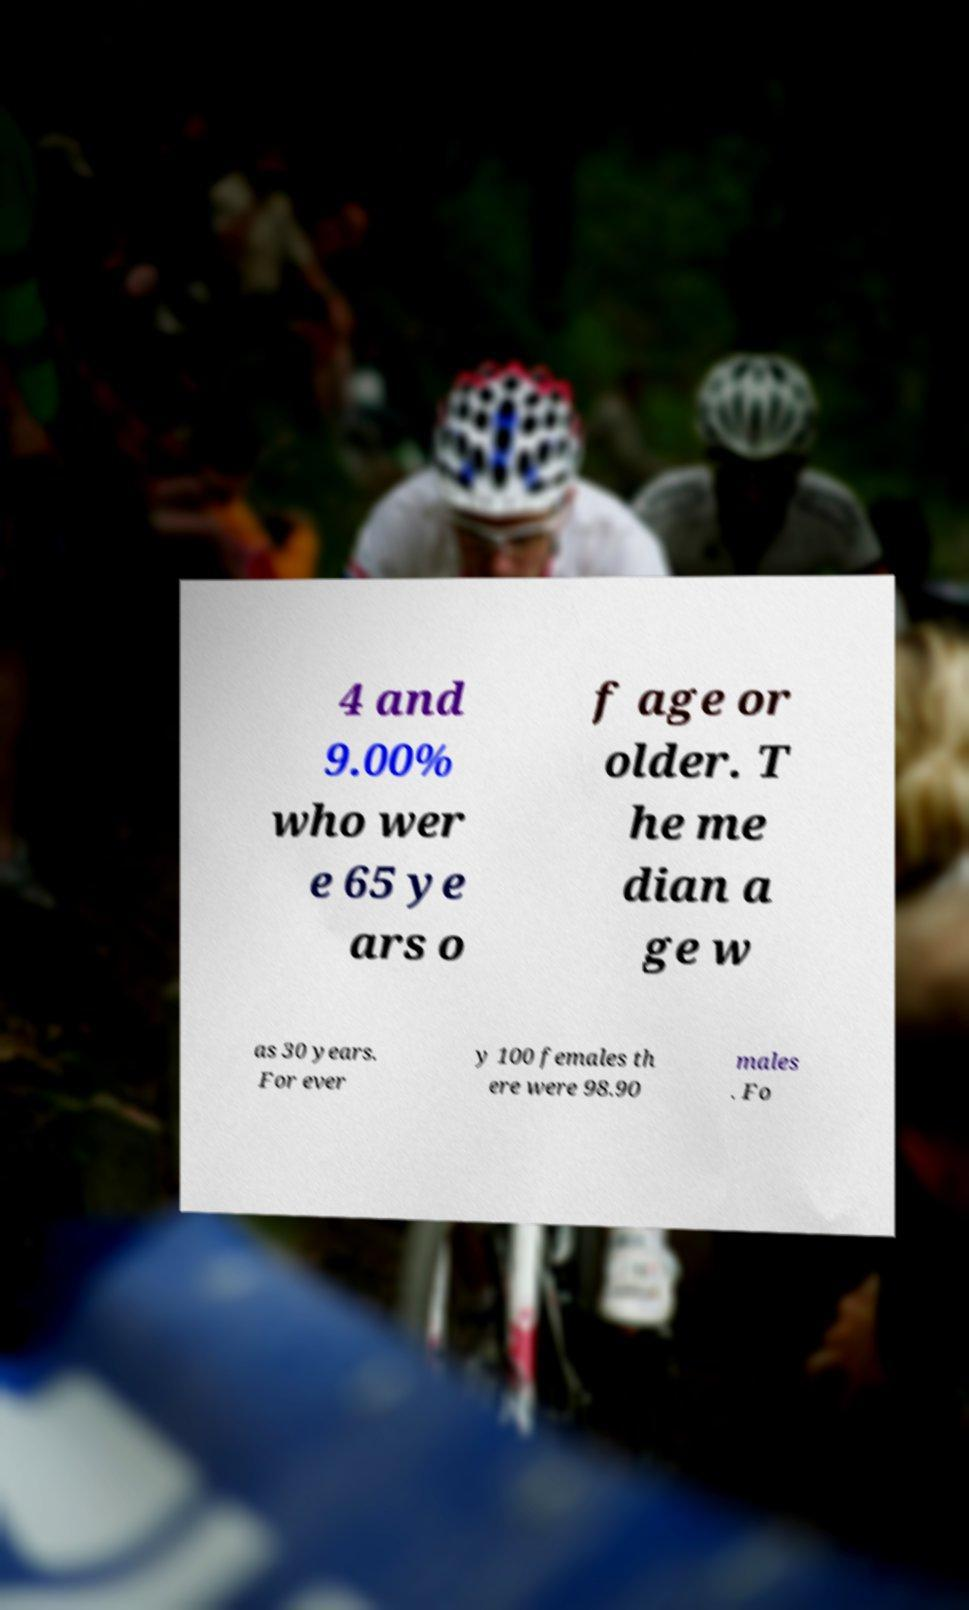Could you extract and type out the text from this image? 4 and 9.00% who wer e 65 ye ars o f age or older. T he me dian a ge w as 30 years. For ever y 100 females th ere were 98.90 males . Fo 